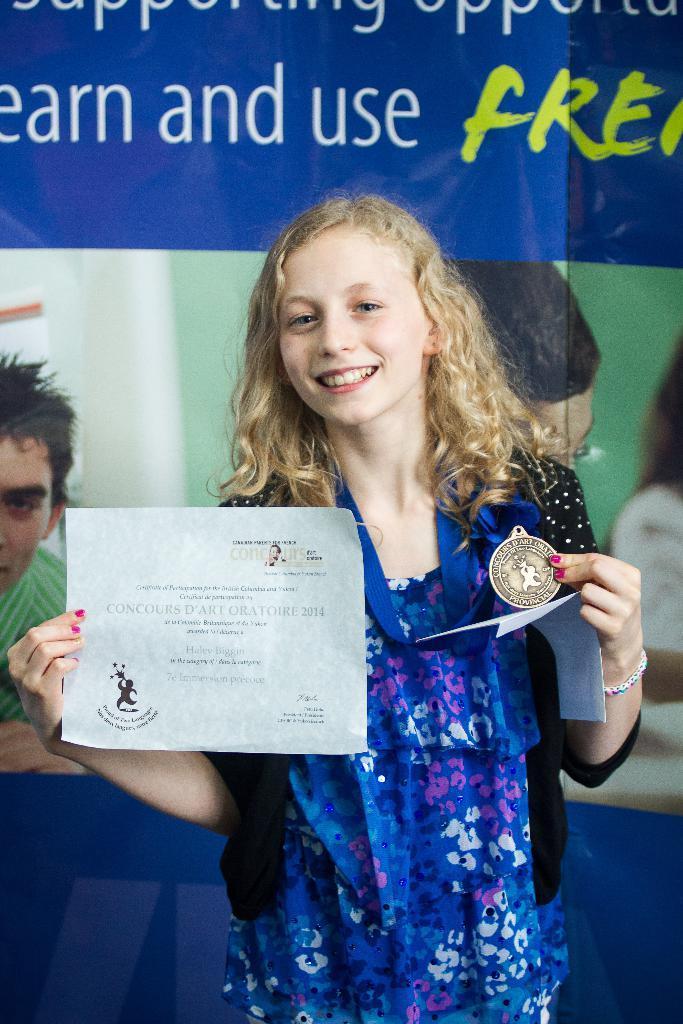Please provide a concise description of this image. In this image I can see the person with the blue, black and pink color dress. I can see the person is holding the medal and the certificate. In the background I can see the banner. 